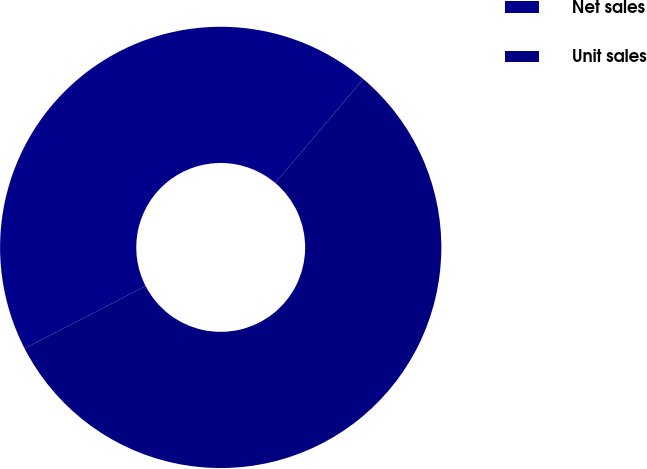Convert chart to OTSL. <chart><loc_0><loc_0><loc_500><loc_500><pie_chart><fcel>Net sales<fcel>Unit sales<nl><fcel>43.75%<fcel>56.25%<nl></chart> 